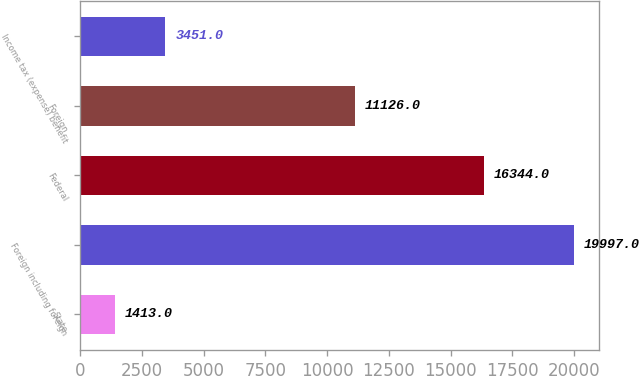Convert chart. <chart><loc_0><loc_0><loc_500><loc_500><bar_chart><fcel>State<fcel>Foreign including foreign<fcel>Federal<fcel>Foreign<fcel>Income tax (expense) benefit<nl><fcel>1413<fcel>19997<fcel>16344<fcel>11126<fcel>3451<nl></chart> 